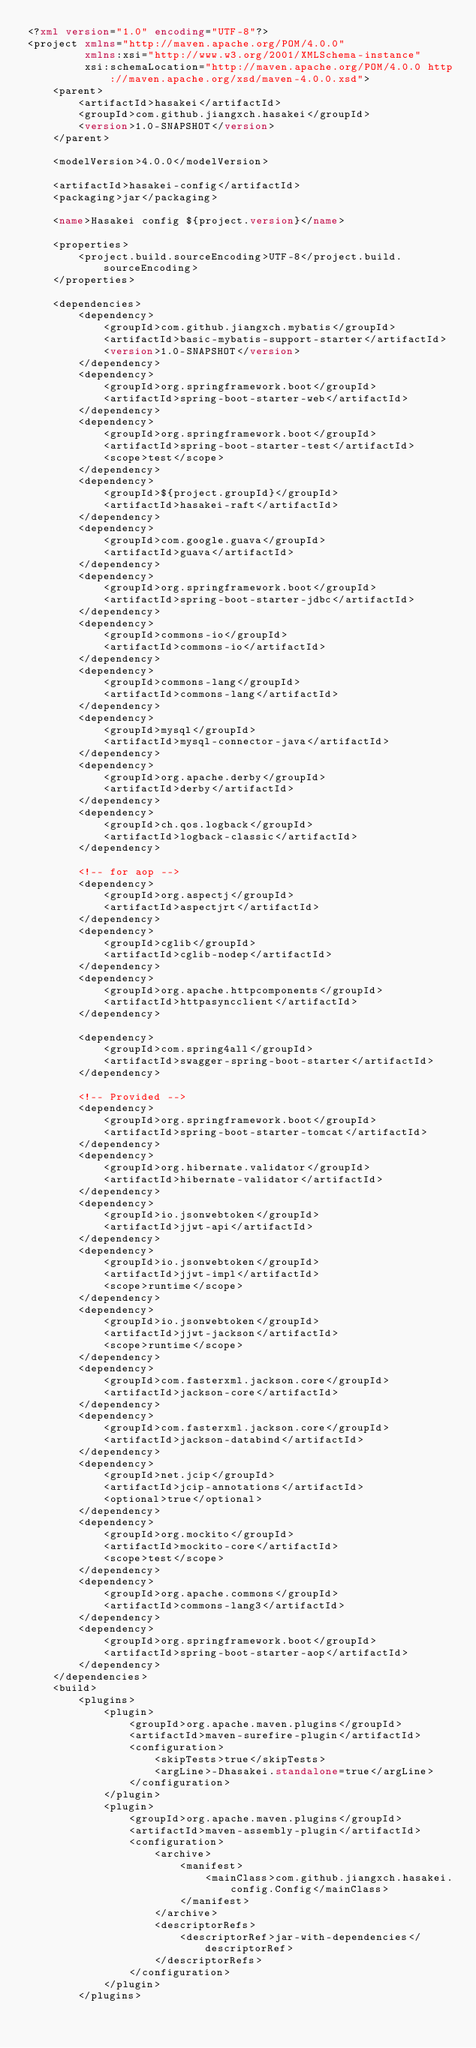<code> <loc_0><loc_0><loc_500><loc_500><_XML_><?xml version="1.0" encoding="UTF-8"?>
<project xmlns="http://maven.apache.org/POM/4.0.0"
         xmlns:xsi="http://www.w3.org/2001/XMLSchema-instance"
         xsi:schemaLocation="http://maven.apache.org/POM/4.0.0 http://maven.apache.org/xsd/maven-4.0.0.xsd">
    <parent>
        <artifactId>hasakei</artifactId>
        <groupId>com.github.jiangxch.hasakei</groupId>
        <version>1.0-SNAPSHOT</version>
    </parent>

    <modelVersion>4.0.0</modelVersion>

    <artifactId>hasakei-config</artifactId>
    <packaging>jar</packaging>

    <name>Hasakei config ${project.version}</name>

    <properties>
        <project.build.sourceEncoding>UTF-8</project.build.sourceEncoding>
    </properties>

    <dependencies>
        <dependency>
            <groupId>com.github.jiangxch.mybatis</groupId>
            <artifactId>basic-mybatis-support-starter</artifactId>
            <version>1.0-SNAPSHOT</version>
        </dependency>
        <dependency>
            <groupId>org.springframework.boot</groupId>
            <artifactId>spring-boot-starter-web</artifactId>
        </dependency>
        <dependency>
            <groupId>org.springframework.boot</groupId>
            <artifactId>spring-boot-starter-test</artifactId>
            <scope>test</scope>
        </dependency>
        <dependency>
            <groupId>${project.groupId}</groupId>
            <artifactId>hasakei-raft</artifactId>
        </dependency>
        <dependency>
            <groupId>com.google.guava</groupId>
            <artifactId>guava</artifactId>
        </dependency>
        <dependency>
            <groupId>org.springframework.boot</groupId>
            <artifactId>spring-boot-starter-jdbc</artifactId>
        </dependency>
        <dependency>
            <groupId>commons-io</groupId>
            <artifactId>commons-io</artifactId>
        </dependency>
        <dependency>
            <groupId>commons-lang</groupId>
            <artifactId>commons-lang</artifactId>
        </dependency>
        <dependency>
            <groupId>mysql</groupId>
            <artifactId>mysql-connector-java</artifactId>
        </dependency>
        <dependency>
            <groupId>org.apache.derby</groupId>
            <artifactId>derby</artifactId>
        </dependency>
        <dependency>
            <groupId>ch.qos.logback</groupId>
            <artifactId>logback-classic</artifactId>
        </dependency>

        <!-- for aop -->
        <dependency>
            <groupId>org.aspectj</groupId>
            <artifactId>aspectjrt</artifactId>
        </dependency>
        <dependency>
            <groupId>cglib</groupId>
            <artifactId>cglib-nodep</artifactId>
        </dependency>
        <dependency>
            <groupId>org.apache.httpcomponents</groupId>
            <artifactId>httpasyncclient</artifactId>
        </dependency>

        <dependency>
            <groupId>com.spring4all</groupId>
            <artifactId>swagger-spring-boot-starter</artifactId>
        </dependency>

        <!-- Provided -->
        <dependency>
            <groupId>org.springframework.boot</groupId>
            <artifactId>spring-boot-starter-tomcat</artifactId>
        </dependency>
        <dependency>
            <groupId>org.hibernate.validator</groupId>
            <artifactId>hibernate-validator</artifactId>
        </dependency>
        <dependency>
            <groupId>io.jsonwebtoken</groupId>
            <artifactId>jjwt-api</artifactId>
        </dependency>
        <dependency>
            <groupId>io.jsonwebtoken</groupId>
            <artifactId>jjwt-impl</artifactId>
            <scope>runtime</scope>
        </dependency>
        <dependency>
            <groupId>io.jsonwebtoken</groupId>
            <artifactId>jjwt-jackson</artifactId>
            <scope>runtime</scope>
        </dependency>
        <dependency>
            <groupId>com.fasterxml.jackson.core</groupId>
            <artifactId>jackson-core</artifactId>
        </dependency>
        <dependency>
            <groupId>com.fasterxml.jackson.core</groupId>
            <artifactId>jackson-databind</artifactId>
        </dependency>
        <dependency>
            <groupId>net.jcip</groupId>
            <artifactId>jcip-annotations</artifactId>
            <optional>true</optional>
        </dependency>
        <dependency>
            <groupId>org.mockito</groupId>
            <artifactId>mockito-core</artifactId>
            <scope>test</scope>
        </dependency>
        <dependency>
            <groupId>org.apache.commons</groupId>
            <artifactId>commons-lang3</artifactId>
        </dependency>
        <dependency>
            <groupId>org.springframework.boot</groupId>
            <artifactId>spring-boot-starter-aop</artifactId>
        </dependency>
    </dependencies>
    <build>
        <plugins>
            <plugin>
                <groupId>org.apache.maven.plugins</groupId>
                <artifactId>maven-surefire-plugin</artifactId>
                <configuration>
                    <skipTests>true</skipTests>
                    <argLine>-Dhasakei.standalone=true</argLine>
                </configuration>
            </plugin>
            <plugin>
                <groupId>org.apache.maven.plugins</groupId>
                <artifactId>maven-assembly-plugin</artifactId>
                <configuration>
                    <archive>
                        <manifest>
                            <mainClass>com.github.jiangxch.hasakei.config.Config</mainClass>
                        </manifest>
                    </archive>
                    <descriptorRefs>
                        <descriptorRef>jar-with-dependencies</descriptorRef>
                    </descriptorRefs>
                </configuration>
            </plugin>
        </plugins></code> 